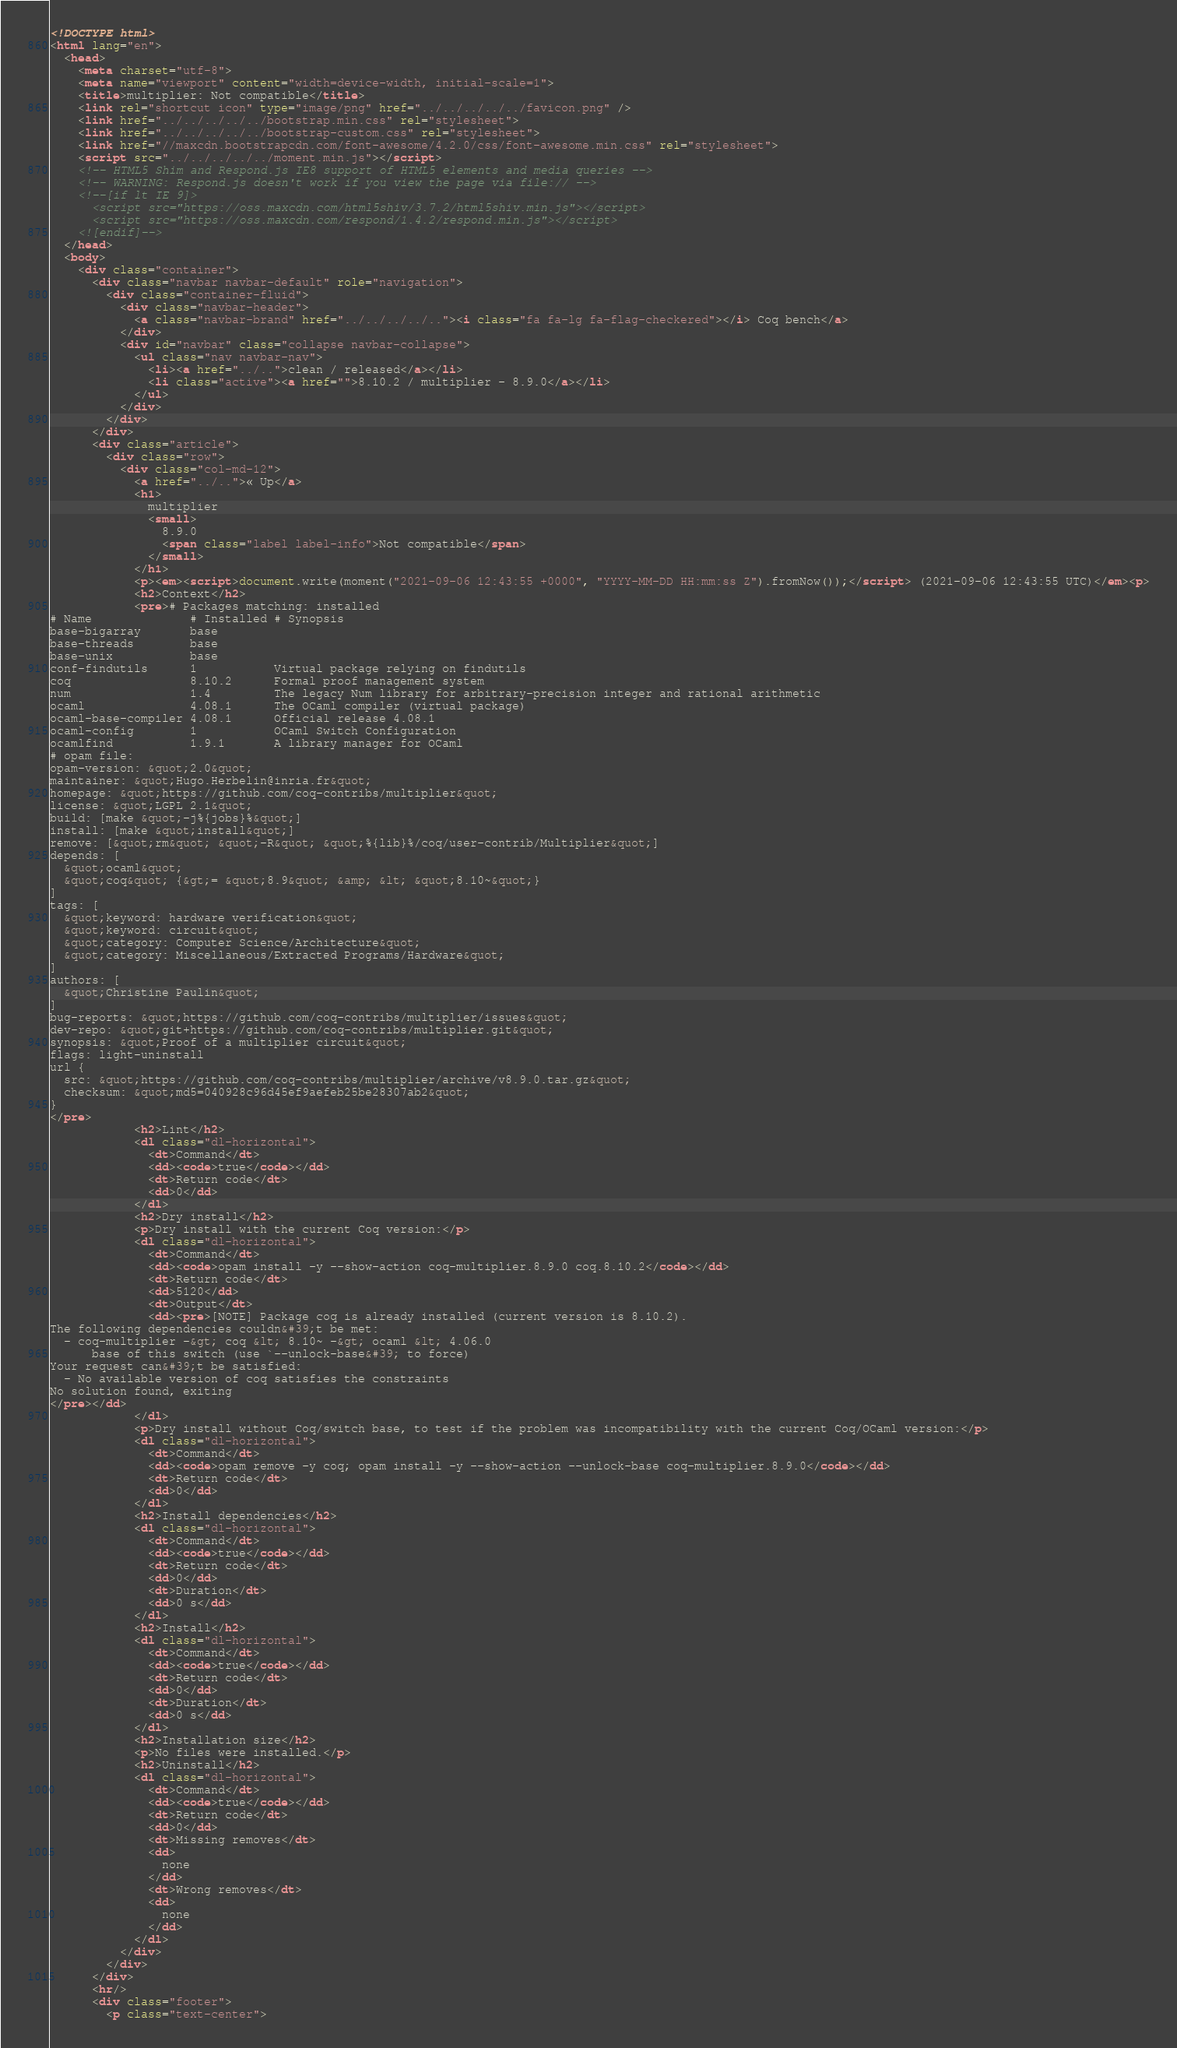Convert code to text. <code><loc_0><loc_0><loc_500><loc_500><_HTML_><!DOCTYPE html>
<html lang="en">
  <head>
    <meta charset="utf-8">
    <meta name="viewport" content="width=device-width, initial-scale=1">
    <title>multiplier: Not compatible</title>
    <link rel="shortcut icon" type="image/png" href="../../../../../favicon.png" />
    <link href="../../../../../bootstrap.min.css" rel="stylesheet">
    <link href="../../../../../bootstrap-custom.css" rel="stylesheet">
    <link href="//maxcdn.bootstrapcdn.com/font-awesome/4.2.0/css/font-awesome.min.css" rel="stylesheet">
    <script src="../../../../../moment.min.js"></script>
    <!-- HTML5 Shim and Respond.js IE8 support of HTML5 elements and media queries -->
    <!-- WARNING: Respond.js doesn't work if you view the page via file:// -->
    <!--[if lt IE 9]>
      <script src="https://oss.maxcdn.com/html5shiv/3.7.2/html5shiv.min.js"></script>
      <script src="https://oss.maxcdn.com/respond/1.4.2/respond.min.js"></script>
    <![endif]-->
  </head>
  <body>
    <div class="container">
      <div class="navbar navbar-default" role="navigation">
        <div class="container-fluid">
          <div class="navbar-header">
            <a class="navbar-brand" href="../../../../.."><i class="fa fa-lg fa-flag-checkered"></i> Coq bench</a>
          </div>
          <div id="navbar" class="collapse navbar-collapse">
            <ul class="nav navbar-nav">
              <li><a href="../..">clean / released</a></li>
              <li class="active"><a href="">8.10.2 / multiplier - 8.9.0</a></li>
            </ul>
          </div>
        </div>
      </div>
      <div class="article">
        <div class="row">
          <div class="col-md-12">
            <a href="../..">« Up</a>
            <h1>
              multiplier
              <small>
                8.9.0
                <span class="label label-info">Not compatible</span>
              </small>
            </h1>
            <p><em><script>document.write(moment("2021-09-06 12:43:55 +0000", "YYYY-MM-DD HH:mm:ss Z").fromNow());</script> (2021-09-06 12:43:55 UTC)</em><p>
            <h2>Context</h2>
            <pre># Packages matching: installed
# Name              # Installed # Synopsis
base-bigarray       base
base-threads        base
base-unix           base
conf-findutils      1           Virtual package relying on findutils
coq                 8.10.2      Formal proof management system
num                 1.4         The legacy Num library for arbitrary-precision integer and rational arithmetic
ocaml               4.08.1      The OCaml compiler (virtual package)
ocaml-base-compiler 4.08.1      Official release 4.08.1
ocaml-config        1           OCaml Switch Configuration
ocamlfind           1.9.1       A library manager for OCaml
# opam file:
opam-version: &quot;2.0&quot;
maintainer: &quot;Hugo.Herbelin@inria.fr&quot;
homepage: &quot;https://github.com/coq-contribs/multiplier&quot;
license: &quot;LGPL 2.1&quot;
build: [make &quot;-j%{jobs}%&quot;]
install: [make &quot;install&quot;]
remove: [&quot;rm&quot; &quot;-R&quot; &quot;%{lib}%/coq/user-contrib/Multiplier&quot;]
depends: [
  &quot;ocaml&quot;
  &quot;coq&quot; {&gt;= &quot;8.9&quot; &amp; &lt; &quot;8.10~&quot;}
]
tags: [
  &quot;keyword: hardware verification&quot;
  &quot;keyword: circuit&quot;
  &quot;category: Computer Science/Architecture&quot;
  &quot;category: Miscellaneous/Extracted Programs/Hardware&quot;
]
authors: [
  &quot;Christine Paulin&quot;
]
bug-reports: &quot;https://github.com/coq-contribs/multiplier/issues&quot;
dev-repo: &quot;git+https://github.com/coq-contribs/multiplier.git&quot;
synopsis: &quot;Proof of a multiplier circuit&quot;
flags: light-uninstall
url {
  src: &quot;https://github.com/coq-contribs/multiplier/archive/v8.9.0.tar.gz&quot;
  checksum: &quot;md5=040928c96d45ef9aefeb25be28307ab2&quot;
}
</pre>
            <h2>Lint</h2>
            <dl class="dl-horizontal">
              <dt>Command</dt>
              <dd><code>true</code></dd>
              <dt>Return code</dt>
              <dd>0</dd>
            </dl>
            <h2>Dry install</h2>
            <p>Dry install with the current Coq version:</p>
            <dl class="dl-horizontal">
              <dt>Command</dt>
              <dd><code>opam install -y --show-action coq-multiplier.8.9.0 coq.8.10.2</code></dd>
              <dt>Return code</dt>
              <dd>5120</dd>
              <dt>Output</dt>
              <dd><pre>[NOTE] Package coq is already installed (current version is 8.10.2).
The following dependencies couldn&#39;t be met:
  - coq-multiplier -&gt; coq &lt; 8.10~ -&gt; ocaml &lt; 4.06.0
      base of this switch (use `--unlock-base&#39; to force)
Your request can&#39;t be satisfied:
  - No available version of coq satisfies the constraints
No solution found, exiting
</pre></dd>
            </dl>
            <p>Dry install without Coq/switch base, to test if the problem was incompatibility with the current Coq/OCaml version:</p>
            <dl class="dl-horizontal">
              <dt>Command</dt>
              <dd><code>opam remove -y coq; opam install -y --show-action --unlock-base coq-multiplier.8.9.0</code></dd>
              <dt>Return code</dt>
              <dd>0</dd>
            </dl>
            <h2>Install dependencies</h2>
            <dl class="dl-horizontal">
              <dt>Command</dt>
              <dd><code>true</code></dd>
              <dt>Return code</dt>
              <dd>0</dd>
              <dt>Duration</dt>
              <dd>0 s</dd>
            </dl>
            <h2>Install</h2>
            <dl class="dl-horizontal">
              <dt>Command</dt>
              <dd><code>true</code></dd>
              <dt>Return code</dt>
              <dd>0</dd>
              <dt>Duration</dt>
              <dd>0 s</dd>
            </dl>
            <h2>Installation size</h2>
            <p>No files were installed.</p>
            <h2>Uninstall</h2>
            <dl class="dl-horizontal">
              <dt>Command</dt>
              <dd><code>true</code></dd>
              <dt>Return code</dt>
              <dd>0</dd>
              <dt>Missing removes</dt>
              <dd>
                none
              </dd>
              <dt>Wrong removes</dt>
              <dd>
                none
              </dd>
            </dl>
          </div>
        </div>
      </div>
      <hr/>
      <div class="footer">
        <p class="text-center"></code> 